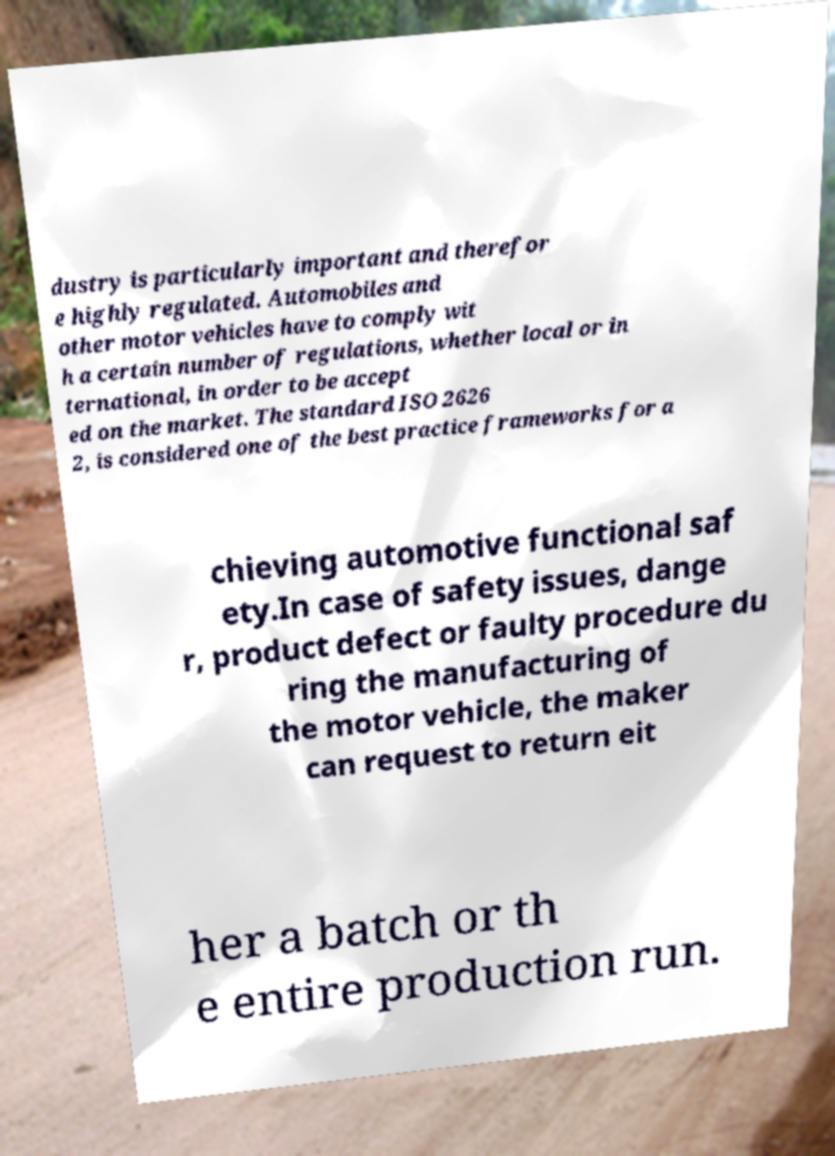For documentation purposes, I need the text within this image transcribed. Could you provide that? dustry is particularly important and therefor e highly regulated. Automobiles and other motor vehicles have to comply wit h a certain number of regulations, whether local or in ternational, in order to be accept ed on the market. The standard ISO 2626 2, is considered one of the best practice frameworks for a chieving automotive functional saf ety.In case of safety issues, dange r, product defect or faulty procedure du ring the manufacturing of the motor vehicle, the maker can request to return eit her a batch or th e entire production run. 